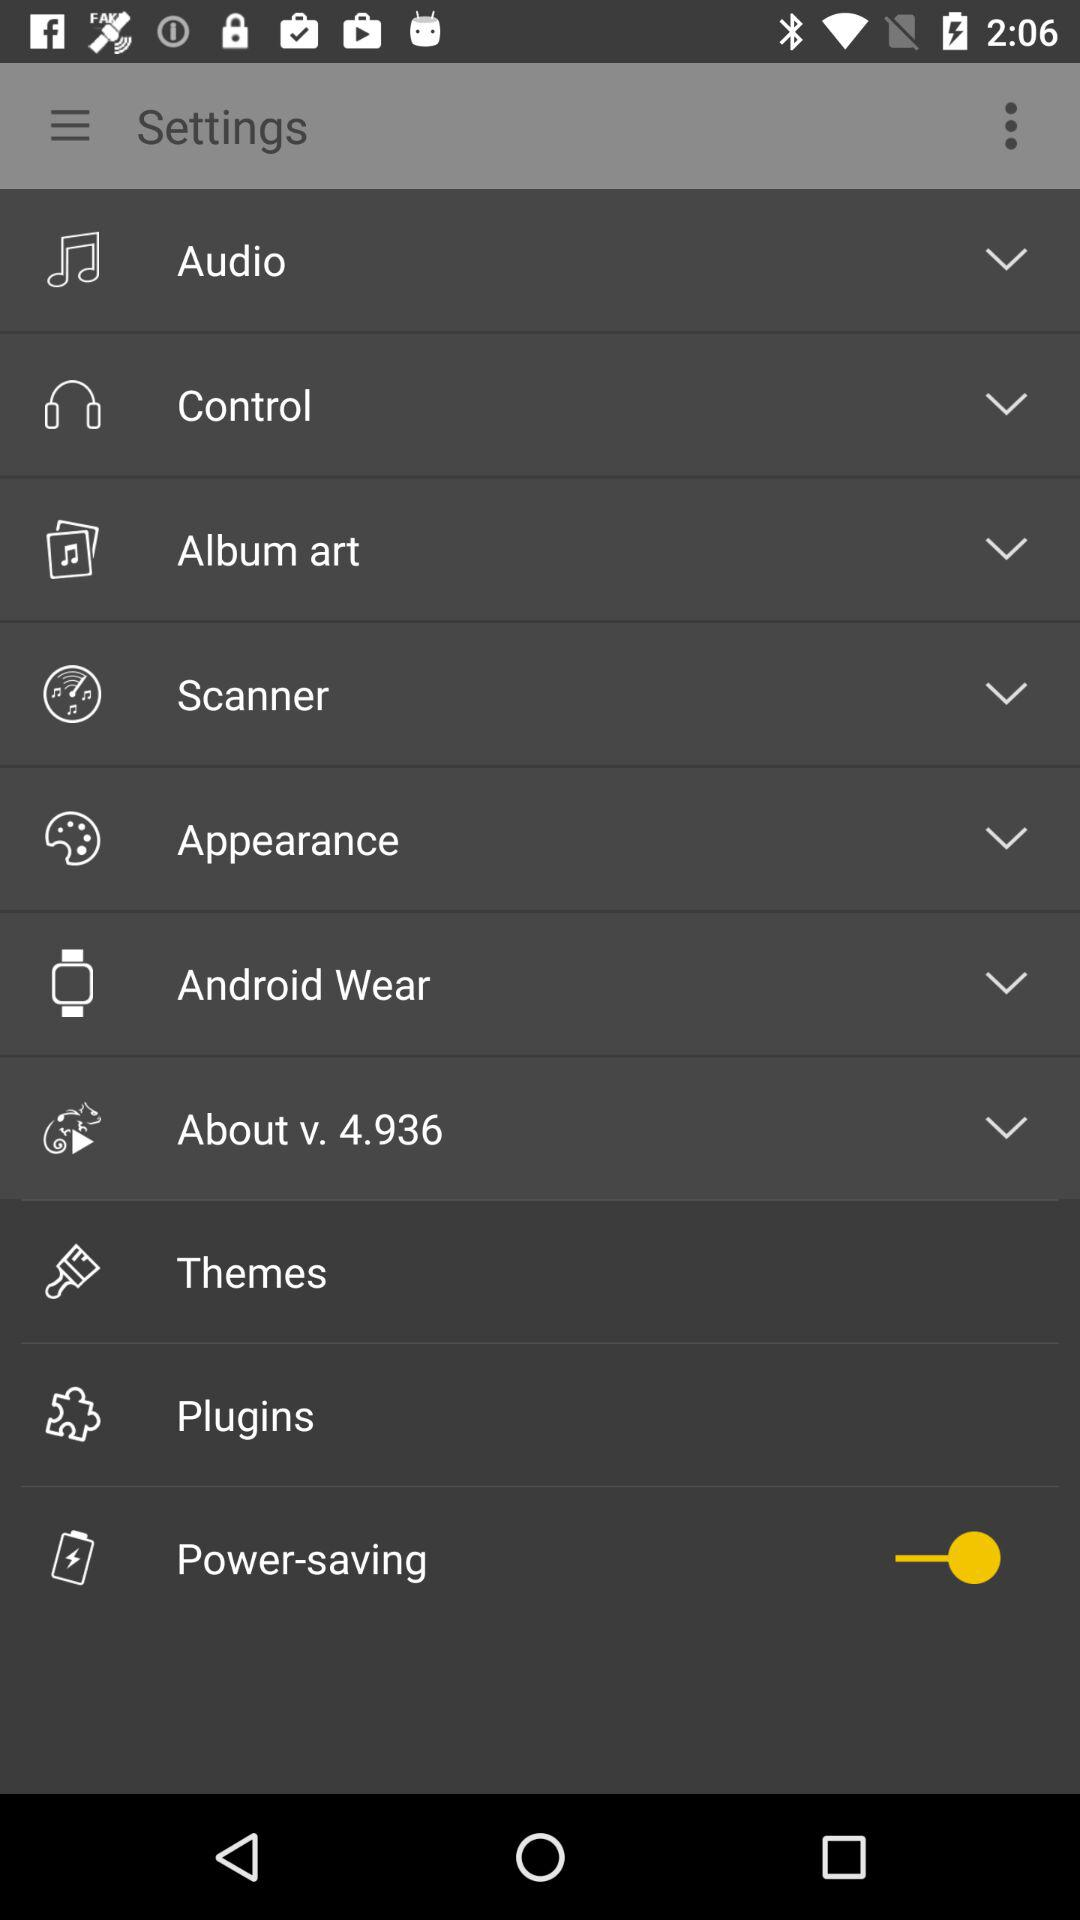What is the status of "Power-saving"? The status of "Power-saving" is "on". 